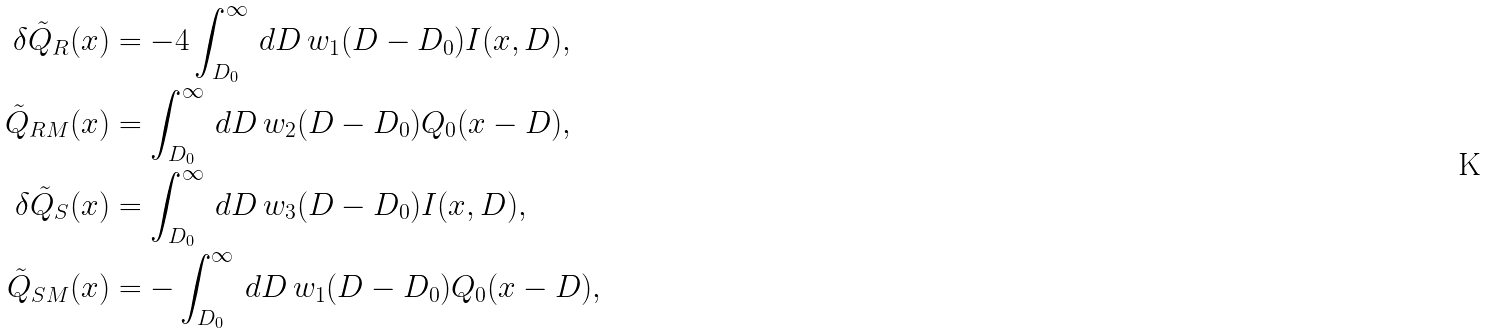Convert formula to latex. <formula><loc_0><loc_0><loc_500><loc_500>\delta \tilde { Q } _ { R } ( x ) & = - 4 \int _ { D _ { 0 } } ^ { \infty } \, d D \, w _ { 1 } ( D - D _ { 0 } ) I ( x , D ) , \\ \tilde { Q } _ { R M } ( x ) & = \int _ { D _ { 0 } } ^ { \infty } \, d D \, w _ { 2 } ( D - D _ { 0 } ) Q _ { 0 } ( x - D ) , \\ \delta \tilde { Q } _ { S } ( x ) & = \int _ { D _ { 0 } } ^ { \infty } \, d D \, w _ { 3 } ( D - D _ { 0 } ) I ( x , D ) , \\ \tilde { Q } _ { S M } ( x ) & = - \int _ { D _ { 0 } } ^ { \infty } \, d D \, w _ { 1 } ( D - D _ { 0 } ) Q _ { 0 } ( x - D ) ,</formula> 